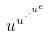Convert formula to latex. <formula><loc_0><loc_0><loc_500><loc_500>u ^ { u ^ { \cdot ^ { \cdot ^ { u ^ { e } } } } }</formula> 